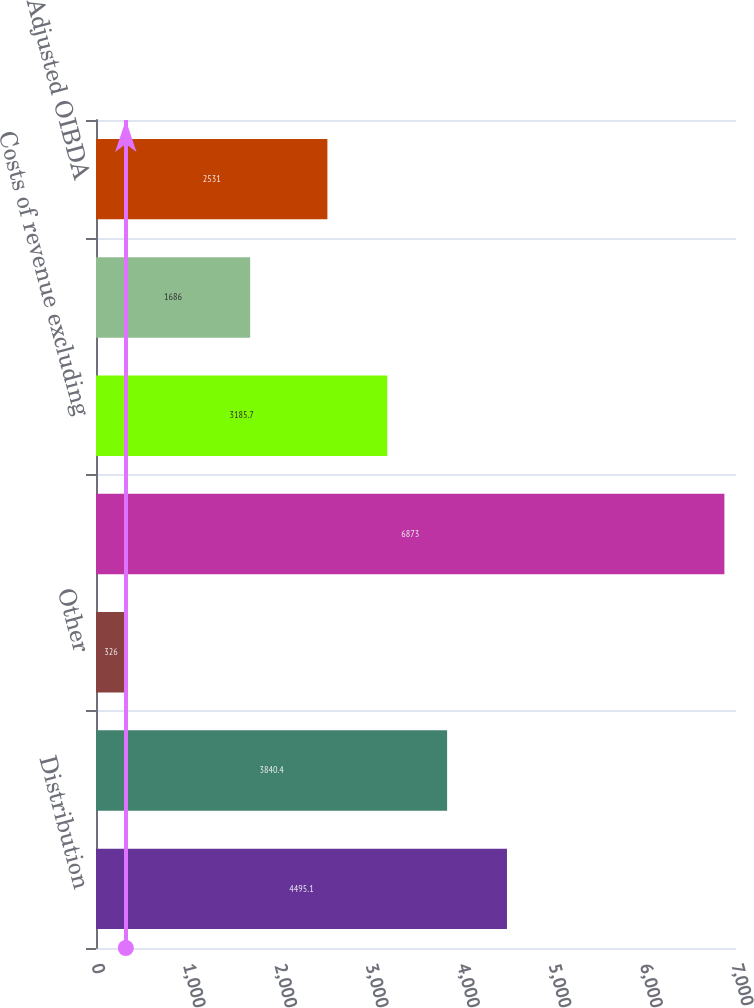<chart> <loc_0><loc_0><loc_500><loc_500><bar_chart><fcel>Distribution<fcel>Advertising<fcel>Other<fcel>Total revenues<fcel>Costs of revenue excluding<fcel>Selling general and<fcel>Adjusted OIBDA<nl><fcel>4495.1<fcel>3840.4<fcel>326<fcel>6873<fcel>3185.7<fcel>1686<fcel>2531<nl></chart> 